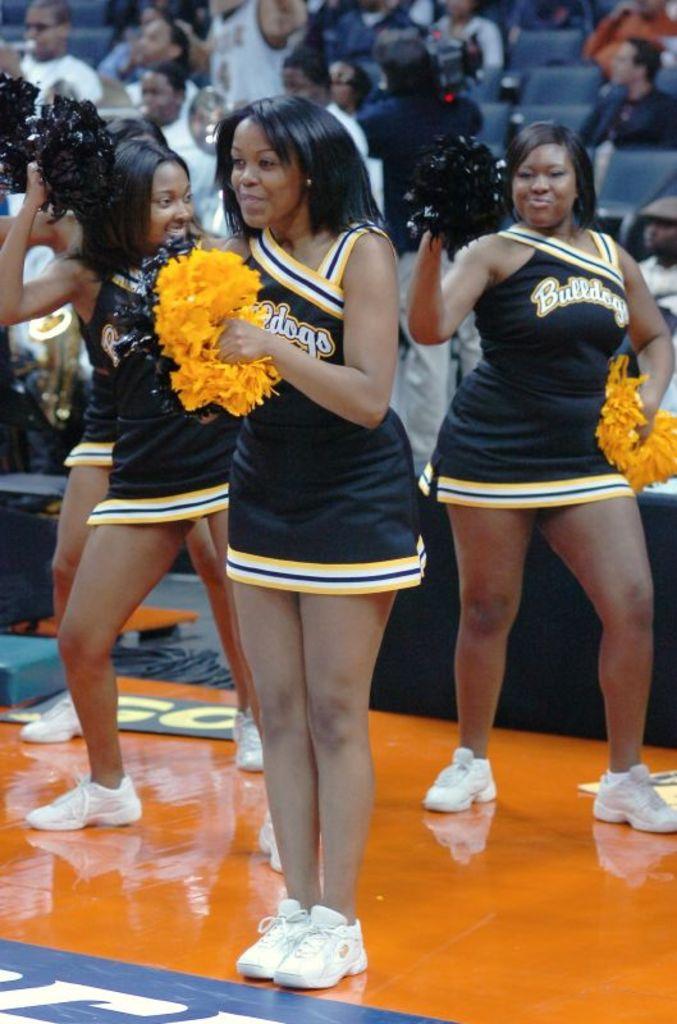What team are these cheerleaders cheering for?
Give a very brief answer. Bulldogs. 